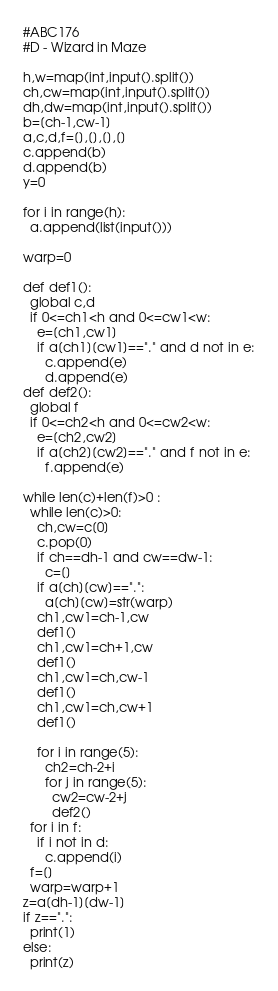Convert code to text. <code><loc_0><loc_0><loc_500><loc_500><_Python_>#ABC176
#D - Wizard in Maze

h,w=map(int,input().split())
ch,cw=map(int,input().split())
dh,dw=map(int,input().split())
b=[ch-1,cw-1]
a,c,d,f=[],[],[],[]
c.append(b)
d.append(b)
y=0

for i in range(h):
  a.append(list(input()))

warp=0

def def1():
  global c,d
  if 0<=ch1<h and 0<=cw1<w:
    e=[ch1,cw1]
    if a[ch1][cw1]=="." and d not in e:
      c.append(e)
      d.append(e)
def def2():
  global f
  if 0<=ch2<h and 0<=cw2<w:
    e=[ch2,cw2]
    if a[ch2][cw2]=="." and f not in e:
      f.append(e)

while len(c)+len(f)>0 :
  while len(c)>0:
    ch,cw=c[0]
    c.pop(0)
    if ch==dh-1 and cw==dw-1:
      c=[]
    if a[ch][cw]==".":
      a[ch][cw]=str(warp)
    ch1,cw1=ch-1,cw
    def1()
    ch1,cw1=ch+1,cw
    def1()
    ch1,cw1=ch,cw-1
    def1()
    ch1,cw1=ch,cw+1
    def1()

    for i in range(5):
      ch2=ch-2+i
      for j in range(5):
        cw2=cw-2+j
        def2()
  for i in f:
    if i not in d:
      c.append(i)
  f=[]
  warp=warp+1
z=a[dh-1][dw-1]
if z==".":
  print(1)
else:
  print(z)</code> 